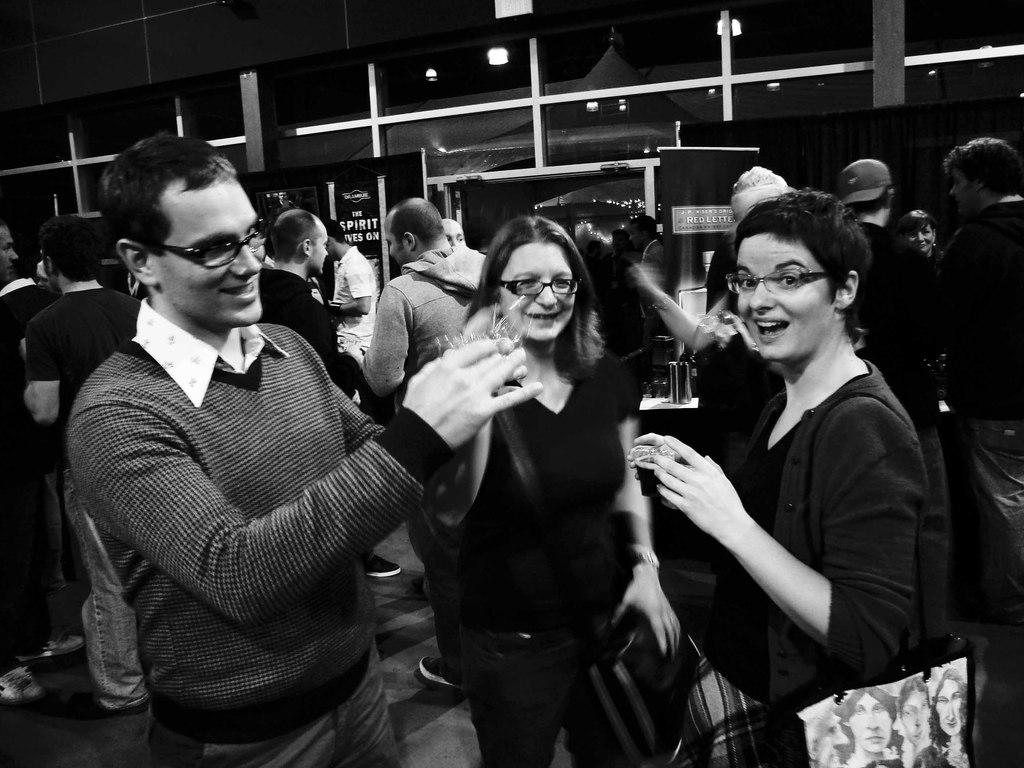What can be seen in the image? There are people standing in the image. What is the surface on which the people are standing? The people are standing on the floor. Can you describe the gender of the people in the image? There are both men and women in the image. What is the color scheme of the image? The image is black and white. How far away is the brother of the person in the image? There is no mention of a brother or any specific person in the image, so it is impossible to determine the distance between them. 